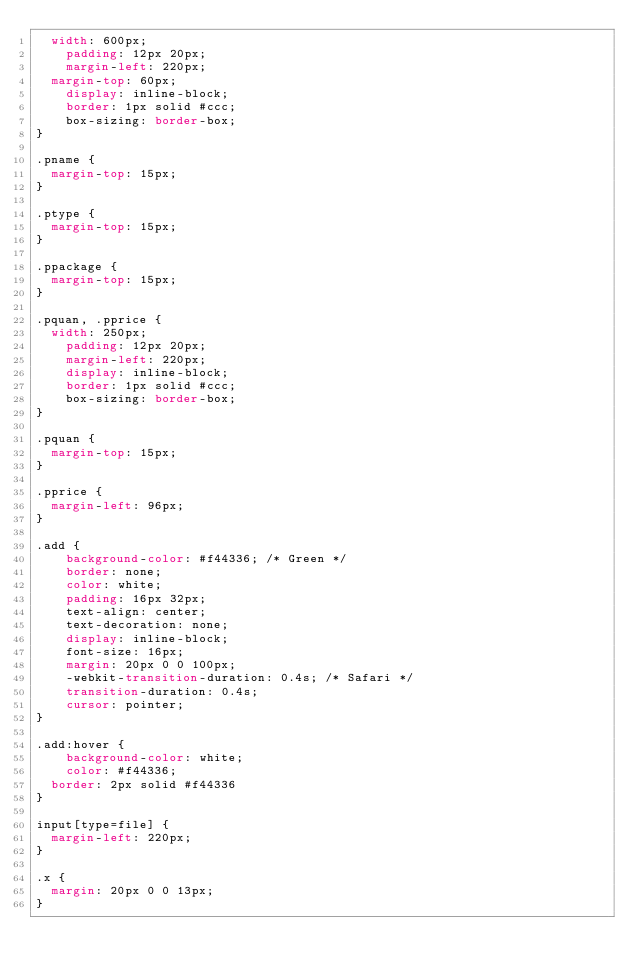Convert code to text. <code><loc_0><loc_0><loc_500><loc_500><_CSS_>	width: 600px;
    padding: 12px 20px;
    margin-left: 220px;
	margin-top: 60px;
    display: inline-block;
    border: 1px solid #ccc;
    box-sizing: border-box;
}	

.pname {
	margin-top: 15px;
}

.ptype {
	margin-top: 15px;
}

.ppackage {
	margin-top: 15px;
}

.pquan, .pprice {
	width: 250px;
    padding: 12px 20px;
    margin-left: 220px;
    display: inline-block;
    border: 1px solid #ccc;
    box-sizing: border-box;
}

.pquan {
	margin-top: 15px;
}

.pprice {
	margin-left: 96px;
}

.add {
    background-color: #f44336; /* Green */
    border: none;
    color: white;
    padding: 16px 32px;
    text-align: center;
    text-decoration: none;
    display: inline-block;
    font-size: 16px;
    margin: 20px 0 0 100px;
    -webkit-transition-duration: 0.4s; /* Safari */
    transition-duration: 0.4s;
    cursor: pointer;
}

.add:hover {
    background-color: white;
    color: #f44336;
	border: 2px solid #f44336
}

input[type=file] {
	margin-left: 220px;
}

.x {
	margin: 20px 0 0 13px;
}

</code> 